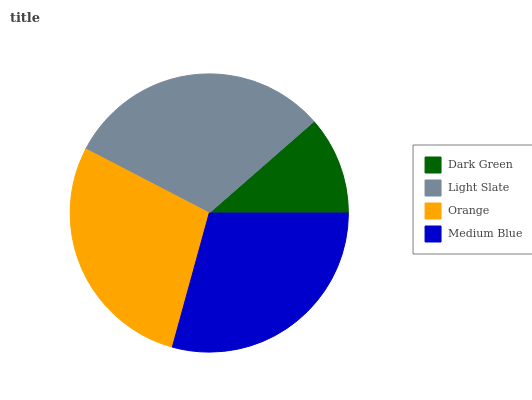Is Dark Green the minimum?
Answer yes or no. Yes. Is Light Slate the maximum?
Answer yes or no. Yes. Is Orange the minimum?
Answer yes or no. No. Is Orange the maximum?
Answer yes or no. No. Is Light Slate greater than Orange?
Answer yes or no. Yes. Is Orange less than Light Slate?
Answer yes or no. Yes. Is Orange greater than Light Slate?
Answer yes or no. No. Is Light Slate less than Orange?
Answer yes or no. No. Is Medium Blue the high median?
Answer yes or no. Yes. Is Orange the low median?
Answer yes or no. Yes. Is Orange the high median?
Answer yes or no. No. Is Medium Blue the low median?
Answer yes or no. No. 